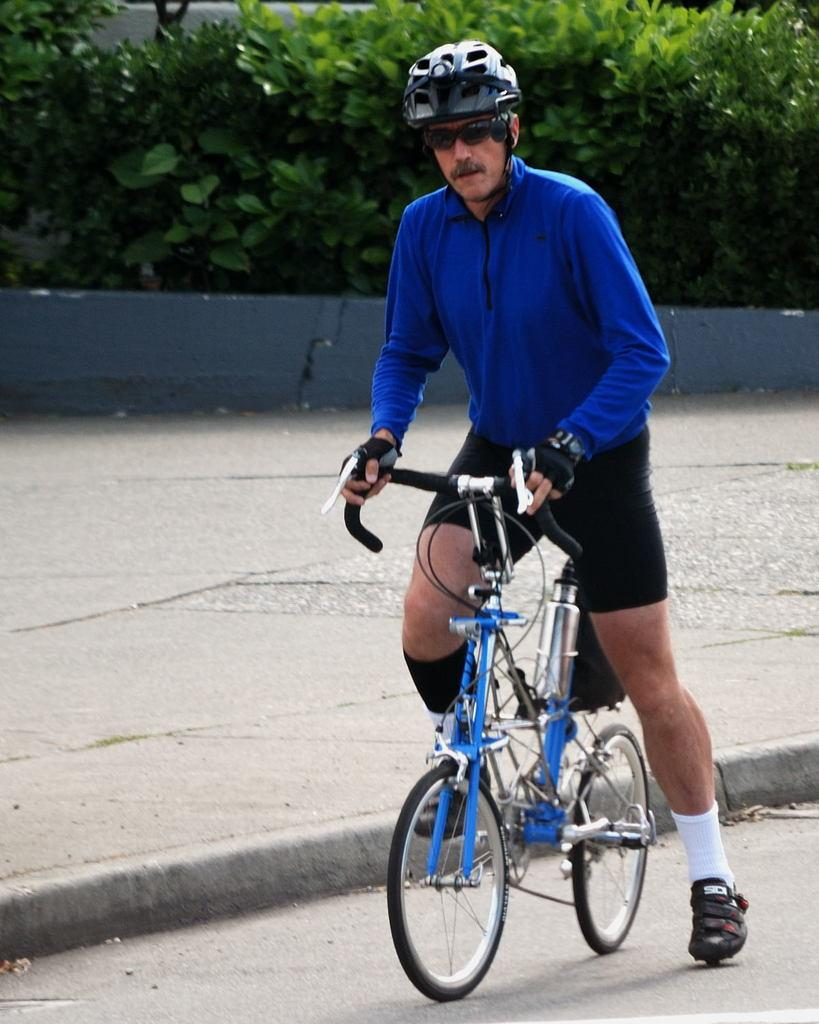Who is the main subject in the image? There is a man in the image. What is the man doing in the image? The man is on a bicycle. Where is the bicycle located in the image? The bicycle is in the center of the image. What can be seen in the background of the image? There are plants and a wall in the background of the image. Can you see the creator of the bicycle in the image? There is no indication of the bicycle's creator in the image. Is there a rabbit riding alongside the man on the bicycle? There is no rabbit present in the image. 